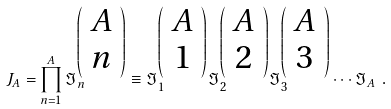Convert formula to latex. <formula><loc_0><loc_0><loc_500><loc_500>J _ { A } = \prod _ { n = 1 } ^ { A } \Im _ { n } ^ { { \left ( \begin{array} { c } A \\ n \end{array} \right ) } } \equiv \Im _ { 1 } ^ { { \left ( \begin{array} { c } A \\ 1 \end{array} \right ) } } \Im _ { 2 } ^ { { \left ( \begin{array} { c } A \\ 2 \end{array} \right ) } } \Im _ { 3 } ^ { { \left ( \begin{array} { c } A \\ 3 \end{array} \right ) } } \cdots \Im _ { A } \ .</formula> 